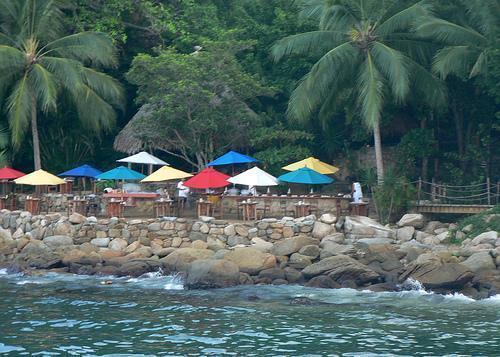What are the trees with one thin trunk called?
Choose the right answer and clarify with the format: 'Answer: answer
Rationale: rationale.'
Options: Willow trees, birch trees, palm trees, pine trees. Answer: palm trees.
Rationale: The trees are seen by the water. 